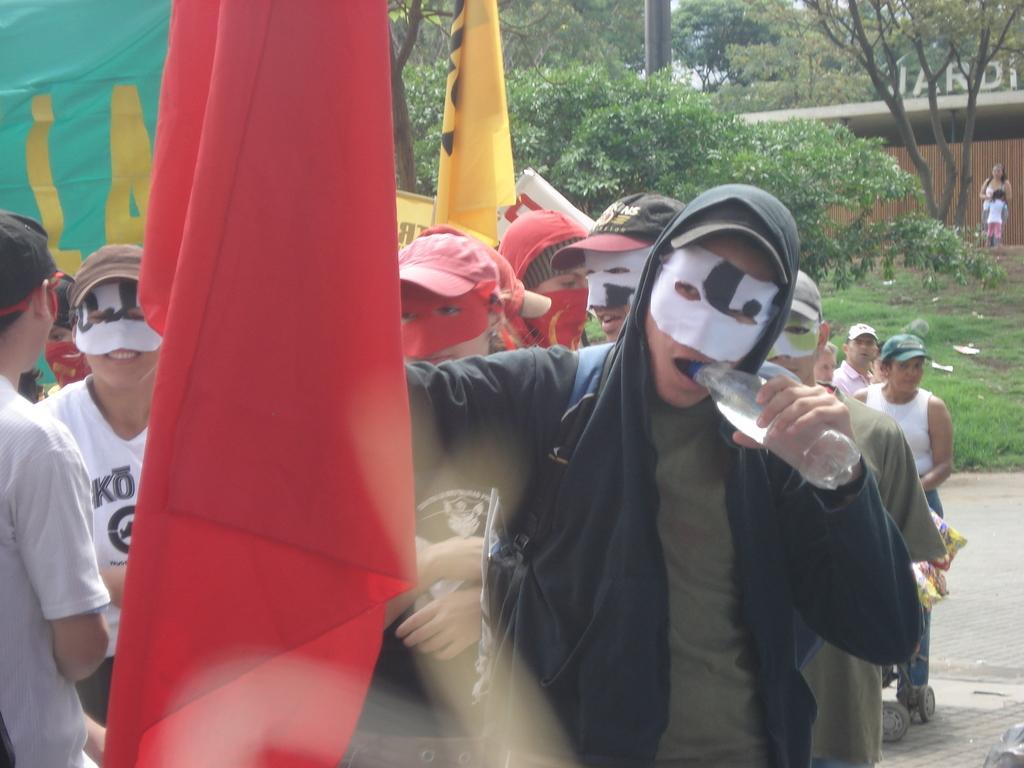In one or two sentences, can you explain what this image depicts? In the image we can see there are people standing and they are wearing mask. The man is holding water bottle in his mouth and behind there is a ground covered with grass. There are trees. 